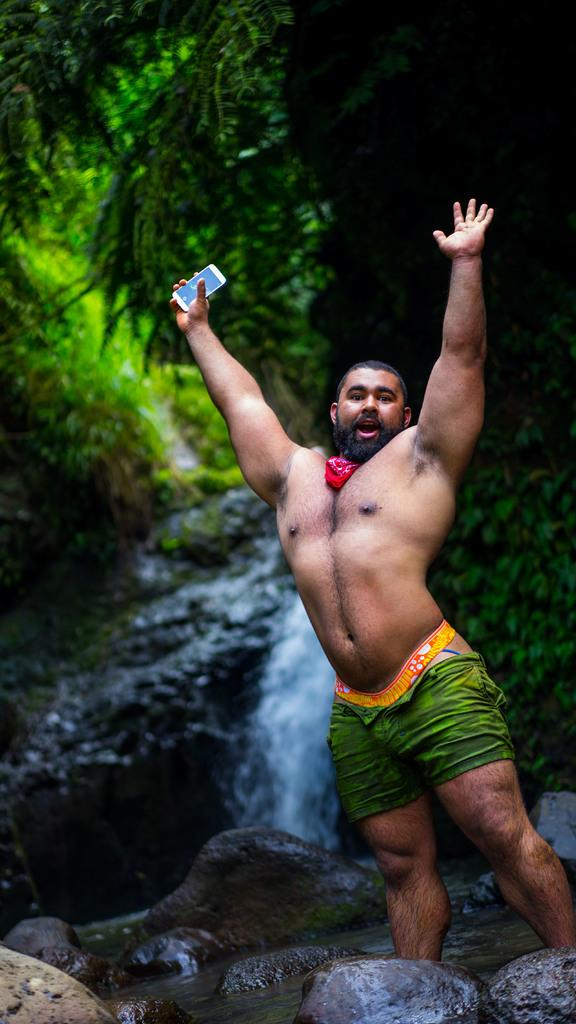What is the man in the image doing? The man is standing in the image. What is the man holding in his hand? The man is holding a mobile in his hand. What can be seen in the background of the image? Water is flowing from rocks and there are trees visible in the image. What type of advice is the coach giving to the committee in the image? There is no coach or committee present in the image. What medical condition is the doctor treating in the image? There is no doctor or medical condition present in the image. 